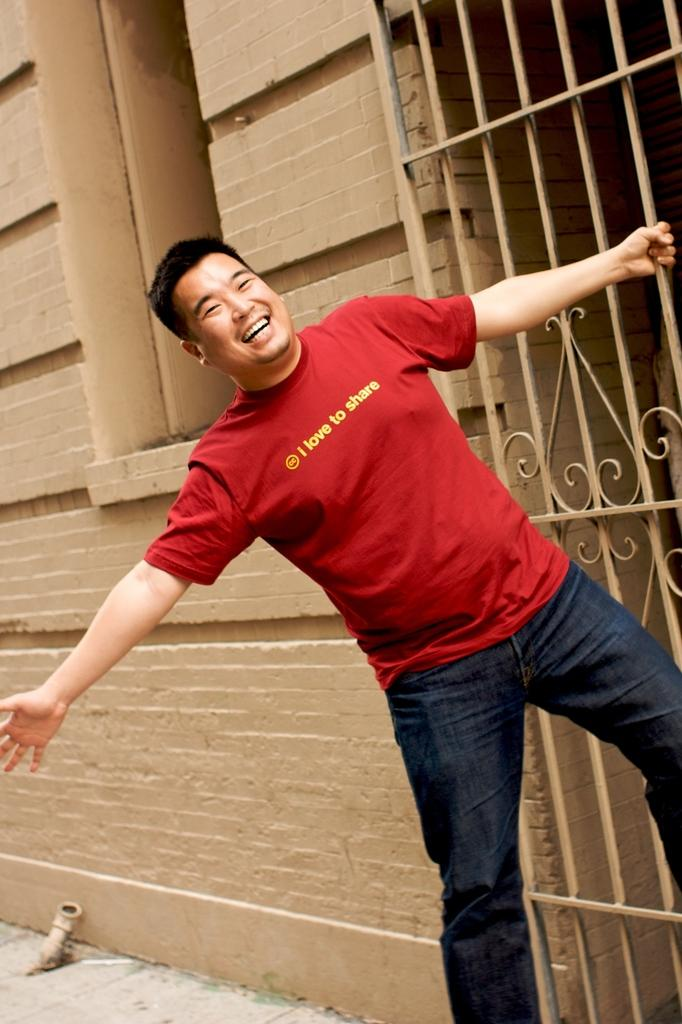What is the main subject of the image? There is a person in the image. What is the person wearing? The person is wearing a red T-shirt and blue jeans. What is the person doing in the image? The person is standing and smiling. What is the person holding in his hand? The person is holding a gate in his hand. What can be seen in the background of the image? There is a wall in the background of the image. How many additions can be seen in the image? There are no additions present in the image. Can you see a tiger in the image? No, there is no tiger in the image. Is the person in the image a parent? The image does not provide any information about the person's parental status, so we cannot determine if they are a parent or not. 